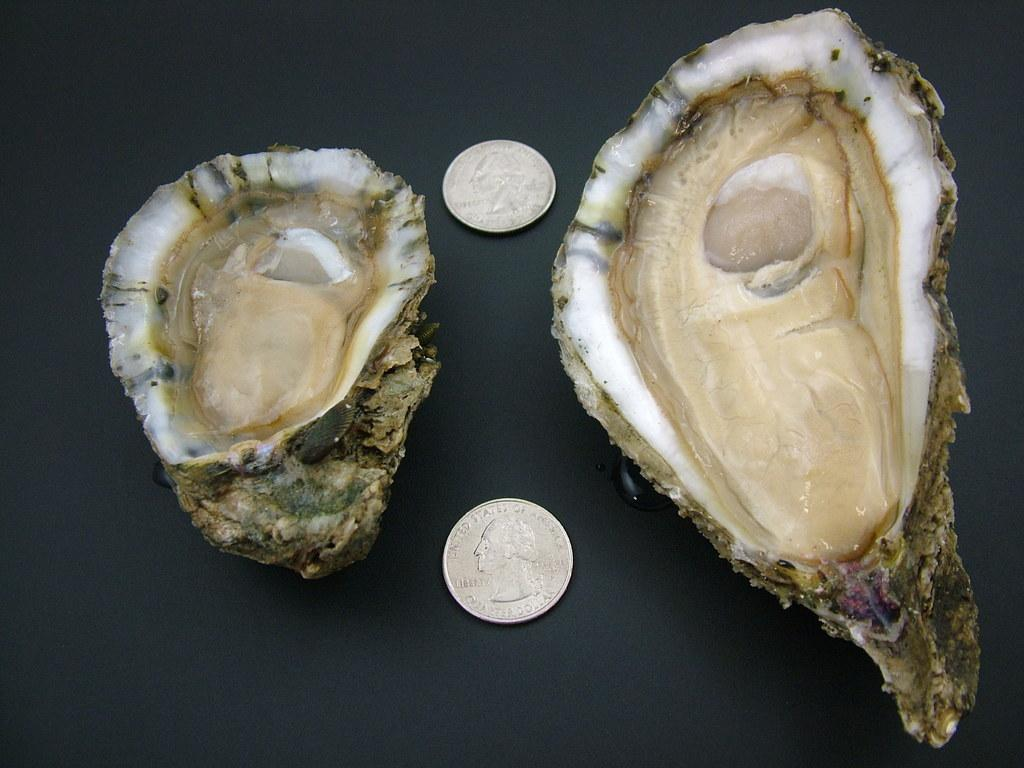What is located in the center of the image? There are shells in the center of the image. What can be found alongside the shells? There are two coins with images and text in the image. How would you describe the overall appearance of the image? The background of the image is dark. What type of treatment is being administered to the shells in the image? There is no treatment being administered to the shells in the image; they are simply located in the center of the image. 